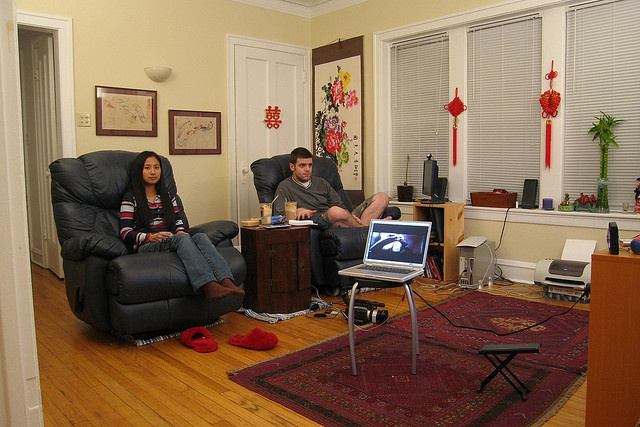Describe the objects in this image and their specific colors. I can see chair in tan, black, gray, and maroon tones, people in tan, black, gray, maroon, and purple tones, chair in tan, black, and gray tones, people in tan, black, brown, and maroon tones, and laptop in tan, navy, white, gray, and darkgray tones in this image. 